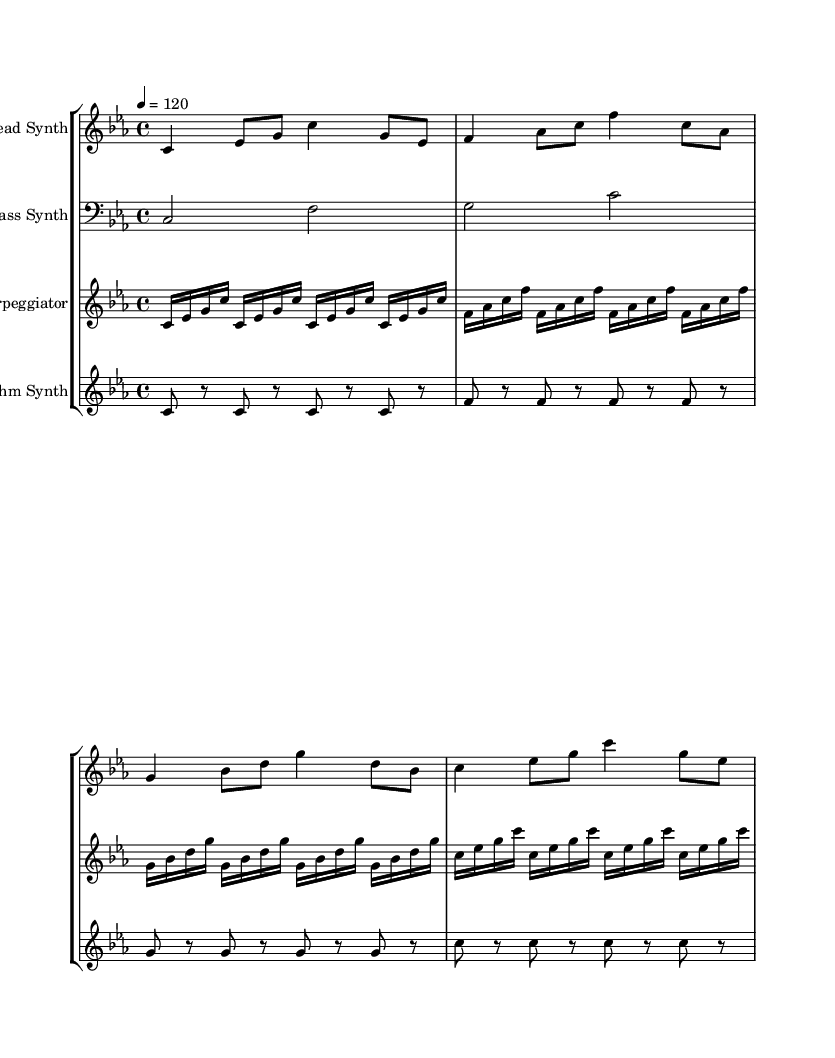What is the key signature of this music? The key signature indicated at the beginning of the score is C minor, which includes three flats (B, E, and A).
Answer: C minor What is the time signature of this composition? The time signature shown at the start of the score is 4/4, indicating four beats per measure and a quarter note gets one beat.
Answer: 4/4 What is the tempo marking for this piece? The tempo marking is set at 4 = 120, which means the quarter note should be played at a speed of 120 beats per minute.
Answer: 120 How many measures are in the lead synth part? By counting the measures indicated in the lead synth notation, there are a total of 8 measures present.
Answer: 8 What type of instrument is associated with the rhythm synth staff? The rhythm synth staff is labeled as "Rhythm Synth," indicating the type of instrument used for this part.
Answer: Rhythm Synth What note pattern is repeated in the arpeggiator section? The arpeggiator section repeats the note pattern "c, es, g," followed by "f, as, c," and so on, highlighting a consistent arpeggiated figure.
Answer: c, es, g Which section features rest notes? In the rhythm synthesizer section, quarter rests (notated as "r") are present, indicating pauses in the rhythm for several beats.
Answer: Rhythm Synth 